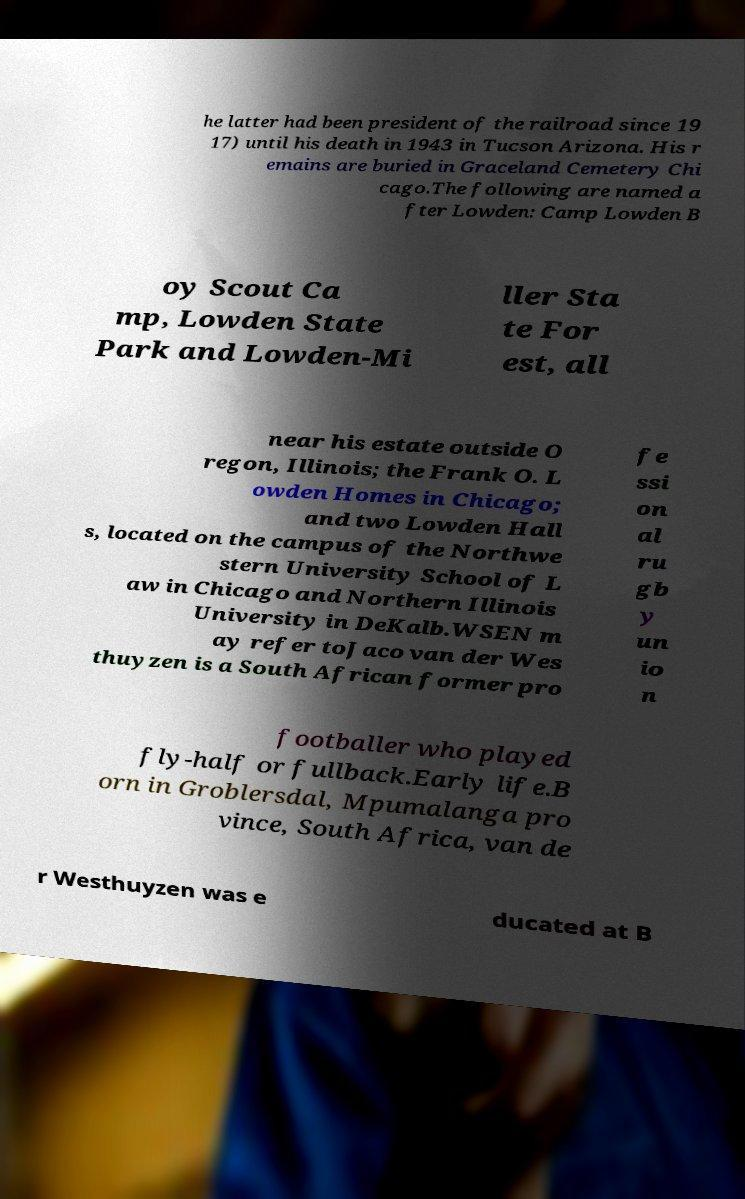Could you assist in decoding the text presented in this image and type it out clearly? he latter had been president of the railroad since 19 17) until his death in 1943 in Tucson Arizona. His r emains are buried in Graceland Cemetery Chi cago.The following are named a fter Lowden: Camp Lowden B oy Scout Ca mp, Lowden State Park and Lowden-Mi ller Sta te For est, all near his estate outside O regon, Illinois; the Frank O. L owden Homes in Chicago; and two Lowden Hall s, located on the campus of the Northwe stern University School of L aw in Chicago and Northern Illinois University in DeKalb.WSEN m ay refer toJaco van der Wes thuyzen is a South African former pro fe ssi on al ru gb y un io n footballer who played fly-half or fullback.Early life.B orn in Groblersdal, Mpumalanga pro vince, South Africa, van de r Westhuyzen was e ducated at B 